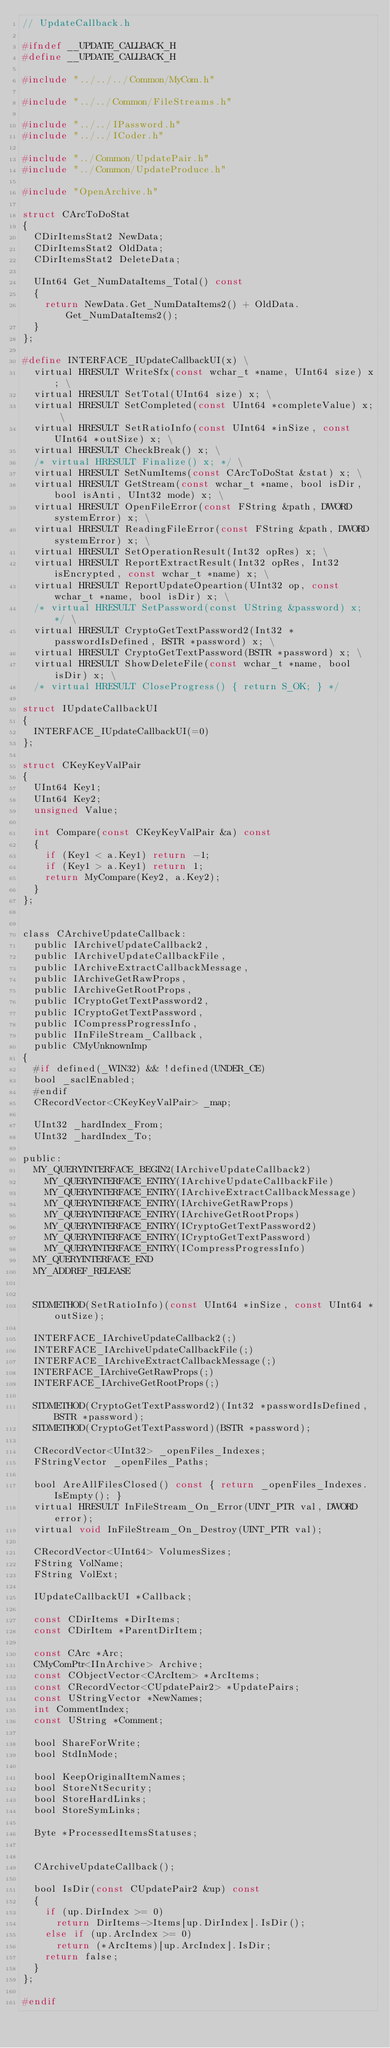Convert code to text. <code><loc_0><loc_0><loc_500><loc_500><_C_>// UpdateCallback.h

#ifndef __UPDATE_CALLBACK_H
#define __UPDATE_CALLBACK_H

#include "../../../Common/MyCom.h"

#include "../../Common/FileStreams.h"

#include "../../IPassword.h"
#include "../../ICoder.h"

#include "../Common/UpdatePair.h"
#include "../Common/UpdateProduce.h"

#include "OpenArchive.h"

struct CArcToDoStat
{
  CDirItemsStat2 NewData;
  CDirItemsStat2 OldData;
  CDirItemsStat2 DeleteData;

  UInt64 Get_NumDataItems_Total() const
  {
    return NewData.Get_NumDataItems2() + OldData.Get_NumDataItems2();
  }
};

#define INTERFACE_IUpdateCallbackUI(x) \
  virtual HRESULT WriteSfx(const wchar_t *name, UInt64 size) x; \
  virtual HRESULT SetTotal(UInt64 size) x; \
  virtual HRESULT SetCompleted(const UInt64 *completeValue) x; \
  virtual HRESULT SetRatioInfo(const UInt64 *inSize, const UInt64 *outSize) x; \
  virtual HRESULT CheckBreak() x; \
  /* virtual HRESULT Finalize() x; */ \
  virtual HRESULT SetNumItems(const CArcToDoStat &stat) x; \
  virtual HRESULT GetStream(const wchar_t *name, bool isDir, bool isAnti, UInt32 mode) x; \
  virtual HRESULT OpenFileError(const FString &path, DWORD systemError) x; \
  virtual HRESULT ReadingFileError(const FString &path, DWORD systemError) x; \
  virtual HRESULT SetOperationResult(Int32 opRes) x; \
  virtual HRESULT ReportExtractResult(Int32 opRes, Int32 isEncrypted, const wchar_t *name) x; \
  virtual HRESULT ReportUpdateOpeartion(UInt32 op, const wchar_t *name, bool isDir) x; \
  /* virtual HRESULT SetPassword(const UString &password) x; */ \
  virtual HRESULT CryptoGetTextPassword2(Int32 *passwordIsDefined, BSTR *password) x; \
  virtual HRESULT CryptoGetTextPassword(BSTR *password) x; \
  virtual HRESULT ShowDeleteFile(const wchar_t *name, bool isDir) x; \
  /* virtual HRESULT CloseProgress() { return S_OK; } */

struct IUpdateCallbackUI
{
  INTERFACE_IUpdateCallbackUI(=0)
};

struct CKeyKeyValPair
{
  UInt64 Key1;
  UInt64 Key2;
  unsigned Value;

  int Compare(const CKeyKeyValPair &a) const
  {
    if (Key1 < a.Key1) return -1;
    if (Key1 > a.Key1) return 1;
    return MyCompare(Key2, a.Key2);
  }
};


class CArchiveUpdateCallback:
  public IArchiveUpdateCallback2,
  public IArchiveUpdateCallbackFile,
  public IArchiveExtractCallbackMessage,
  public IArchiveGetRawProps,
  public IArchiveGetRootProps,
  public ICryptoGetTextPassword2,
  public ICryptoGetTextPassword,
  public ICompressProgressInfo,
  public IInFileStream_Callback,
  public CMyUnknownImp
{
  #if defined(_WIN32) && !defined(UNDER_CE)
  bool _saclEnabled;
  #endif
  CRecordVector<CKeyKeyValPair> _map;

  UInt32 _hardIndex_From;
  UInt32 _hardIndex_To;

public:
  MY_QUERYINTERFACE_BEGIN2(IArchiveUpdateCallback2)
    MY_QUERYINTERFACE_ENTRY(IArchiveUpdateCallbackFile)
    MY_QUERYINTERFACE_ENTRY(IArchiveExtractCallbackMessage)
    MY_QUERYINTERFACE_ENTRY(IArchiveGetRawProps)
    MY_QUERYINTERFACE_ENTRY(IArchiveGetRootProps)
    MY_QUERYINTERFACE_ENTRY(ICryptoGetTextPassword2)
    MY_QUERYINTERFACE_ENTRY(ICryptoGetTextPassword)
    MY_QUERYINTERFACE_ENTRY(ICompressProgressInfo)
  MY_QUERYINTERFACE_END
  MY_ADDREF_RELEASE


  STDMETHOD(SetRatioInfo)(const UInt64 *inSize, const UInt64 *outSize);

  INTERFACE_IArchiveUpdateCallback2(;)
  INTERFACE_IArchiveUpdateCallbackFile(;)
  INTERFACE_IArchiveExtractCallbackMessage(;)
  INTERFACE_IArchiveGetRawProps(;)
  INTERFACE_IArchiveGetRootProps(;)

  STDMETHOD(CryptoGetTextPassword2)(Int32 *passwordIsDefined, BSTR *password);
  STDMETHOD(CryptoGetTextPassword)(BSTR *password);

  CRecordVector<UInt32> _openFiles_Indexes;
  FStringVector _openFiles_Paths;

  bool AreAllFilesClosed() const { return _openFiles_Indexes.IsEmpty(); }
  virtual HRESULT InFileStream_On_Error(UINT_PTR val, DWORD error);
  virtual void InFileStream_On_Destroy(UINT_PTR val);

  CRecordVector<UInt64> VolumesSizes;
  FString VolName;
  FString VolExt;

  IUpdateCallbackUI *Callback;

  const CDirItems *DirItems;
  const CDirItem *ParentDirItem;
  
  const CArc *Arc;
  CMyComPtr<IInArchive> Archive;
  const CObjectVector<CArcItem> *ArcItems;
  const CRecordVector<CUpdatePair2> *UpdatePairs;
  const UStringVector *NewNames;
  int CommentIndex;
  const UString *Comment;

  bool ShareForWrite;
  bool StdInMode;

  bool KeepOriginalItemNames;
  bool StoreNtSecurity;
  bool StoreHardLinks;
  bool StoreSymLinks;

  Byte *ProcessedItemsStatuses;


  CArchiveUpdateCallback();

  bool IsDir(const CUpdatePair2 &up) const
  {
    if (up.DirIndex >= 0)
      return DirItems->Items[up.DirIndex].IsDir();
    else if (up.ArcIndex >= 0)
      return (*ArcItems)[up.ArcIndex].IsDir;
    return false;
  }
};

#endif
</code> 